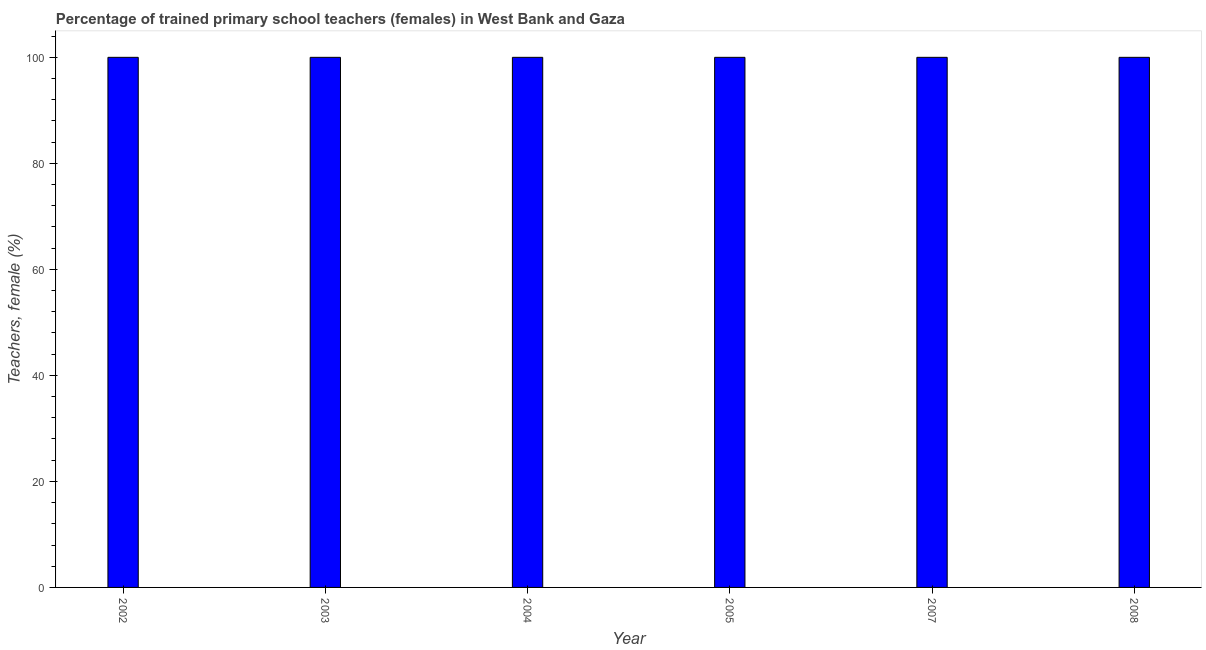Does the graph contain any zero values?
Provide a succinct answer. No. What is the title of the graph?
Your answer should be compact. Percentage of trained primary school teachers (females) in West Bank and Gaza. What is the label or title of the X-axis?
Provide a succinct answer. Year. What is the label or title of the Y-axis?
Your answer should be very brief. Teachers, female (%). Across all years, what is the minimum percentage of trained female teachers?
Keep it short and to the point. 100. In which year was the percentage of trained female teachers maximum?
Offer a very short reply. 2002. What is the sum of the percentage of trained female teachers?
Offer a terse response. 600. What is the difference between the percentage of trained female teachers in 2005 and 2008?
Give a very brief answer. 0. What is the average percentage of trained female teachers per year?
Ensure brevity in your answer.  100. What is the median percentage of trained female teachers?
Provide a succinct answer. 100. Do a majority of the years between 2003 and 2008 (inclusive) have percentage of trained female teachers greater than 20 %?
Ensure brevity in your answer.  Yes. What is the ratio of the percentage of trained female teachers in 2003 to that in 2005?
Give a very brief answer. 1. What is the difference between the highest and the second highest percentage of trained female teachers?
Keep it short and to the point. 0. Is the sum of the percentage of trained female teachers in 2003 and 2008 greater than the maximum percentage of trained female teachers across all years?
Ensure brevity in your answer.  Yes. How many bars are there?
Provide a succinct answer. 6. How many years are there in the graph?
Make the answer very short. 6. What is the difference between two consecutive major ticks on the Y-axis?
Give a very brief answer. 20. Are the values on the major ticks of Y-axis written in scientific E-notation?
Provide a succinct answer. No. What is the Teachers, female (%) in 2003?
Your answer should be very brief. 100. What is the Teachers, female (%) in 2004?
Your answer should be very brief. 100. What is the difference between the Teachers, female (%) in 2002 and 2004?
Your response must be concise. 0. What is the difference between the Teachers, female (%) in 2002 and 2008?
Give a very brief answer. 0. What is the difference between the Teachers, female (%) in 2003 and 2004?
Keep it short and to the point. 0. What is the difference between the Teachers, female (%) in 2003 and 2008?
Give a very brief answer. 0. What is the difference between the Teachers, female (%) in 2004 and 2007?
Ensure brevity in your answer.  0. What is the difference between the Teachers, female (%) in 2005 and 2008?
Provide a short and direct response. 0. What is the difference between the Teachers, female (%) in 2007 and 2008?
Ensure brevity in your answer.  0. What is the ratio of the Teachers, female (%) in 2002 to that in 2003?
Your answer should be very brief. 1. What is the ratio of the Teachers, female (%) in 2002 to that in 2004?
Make the answer very short. 1. What is the ratio of the Teachers, female (%) in 2002 to that in 2005?
Your response must be concise. 1. What is the ratio of the Teachers, female (%) in 2002 to that in 2007?
Offer a very short reply. 1. What is the ratio of the Teachers, female (%) in 2003 to that in 2004?
Offer a very short reply. 1. What is the ratio of the Teachers, female (%) in 2003 to that in 2008?
Make the answer very short. 1. What is the ratio of the Teachers, female (%) in 2004 to that in 2005?
Offer a terse response. 1. What is the ratio of the Teachers, female (%) in 2004 to that in 2008?
Ensure brevity in your answer.  1. 